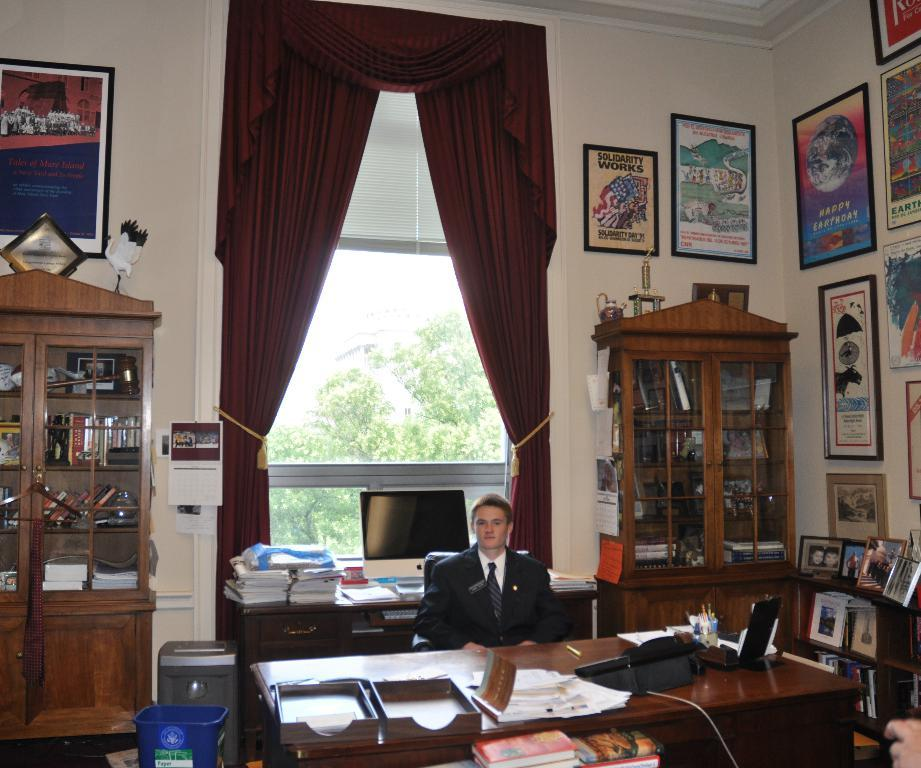<image>
Give a short and clear explanation of the subsequent image. A man is in a huge office with a Solidarity picture behind him. 